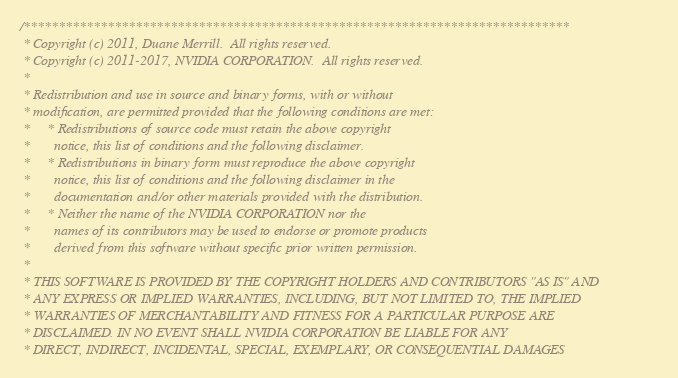Convert code to text. <code><loc_0><loc_0><loc_500><loc_500><_Cuda_>/******************************************************************************
 * Copyright (c) 2011, Duane Merrill.  All rights reserved.
 * Copyright (c) 2011-2017, NVIDIA CORPORATION.  All rights reserved.
 * 
 * Redistribution and use in source and binary forms, with or without
 * modification, are permitted provided that the following conditions are met:
 *     * Redistributions of source code must retain the above copyright
 *       notice, this list of conditions and the following disclaimer.
 *     * Redistributions in binary form must reproduce the above copyright
 *       notice, this list of conditions and the following disclaimer in the
 *       documentation and/or other materials provided with the distribution.
 *     * Neither the name of the NVIDIA CORPORATION nor the
 *       names of its contributors may be used to endorse or promote products
 *       derived from this software without specific prior written permission.
 * 
 * THIS SOFTWARE IS PROVIDED BY THE COPYRIGHT HOLDERS AND CONTRIBUTORS "AS IS" AND
 * ANY EXPRESS OR IMPLIED WARRANTIES, INCLUDING, BUT NOT LIMITED TO, THE IMPLIED
 * WARRANTIES OF MERCHANTABILITY AND FITNESS FOR A PARTICULAR PURPOSE ARE
 * DISCLAIMED. IN NO EVENT SHALL NVIDIA CORPORATION BE LIABLE FOR ANY
 * DIRECT, INDIRECT, INCIDENTAL, SPECIAL, EXEMPLARY, OR CONSEQUENTIAL DAMAGES</code> 